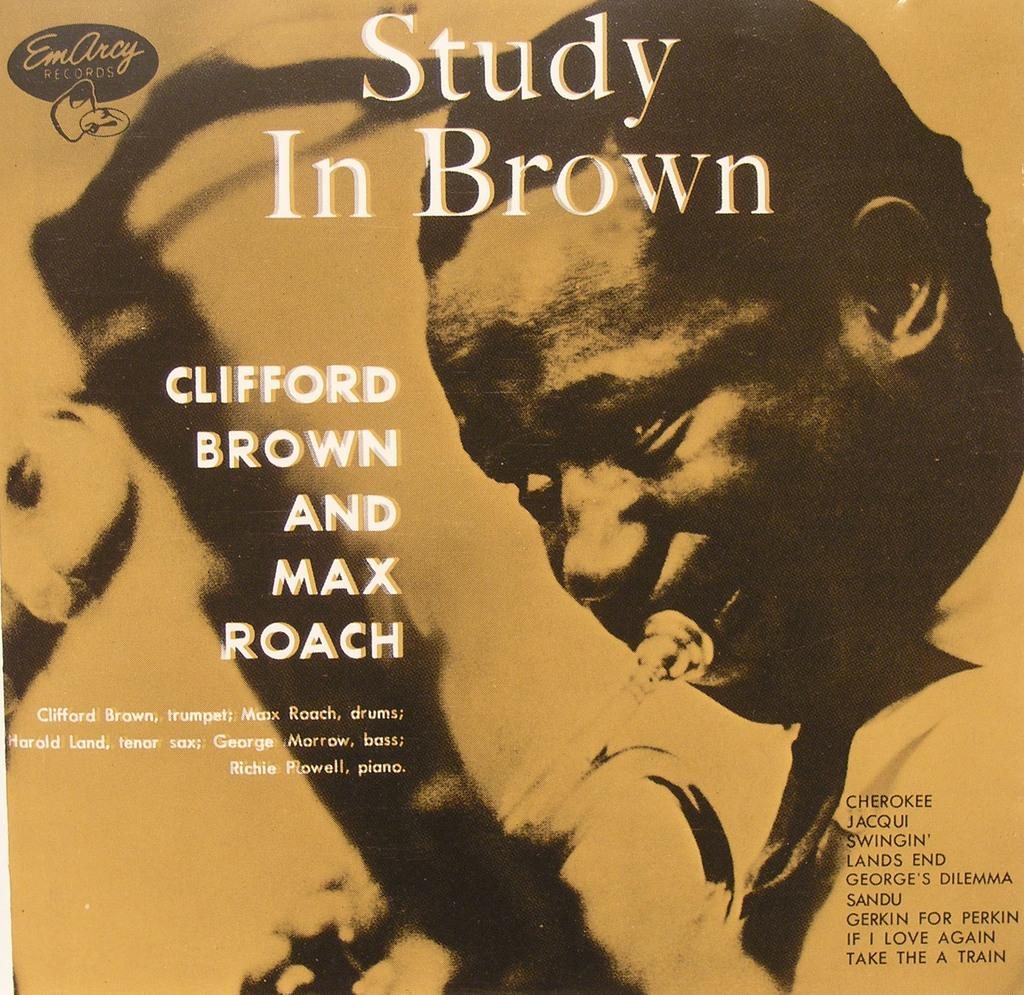What is the main subject of the poster in the image? The poster features a person playing a musical instrument. What else can be seen on the poster besides the person playing the instrument? There is text on the poster. Where is the key hidden in the image? There is no key present in the image. What type of bomb is depicted on the poster? There is no bomb depicted on the poster; it features a person playing a musical instrument. 